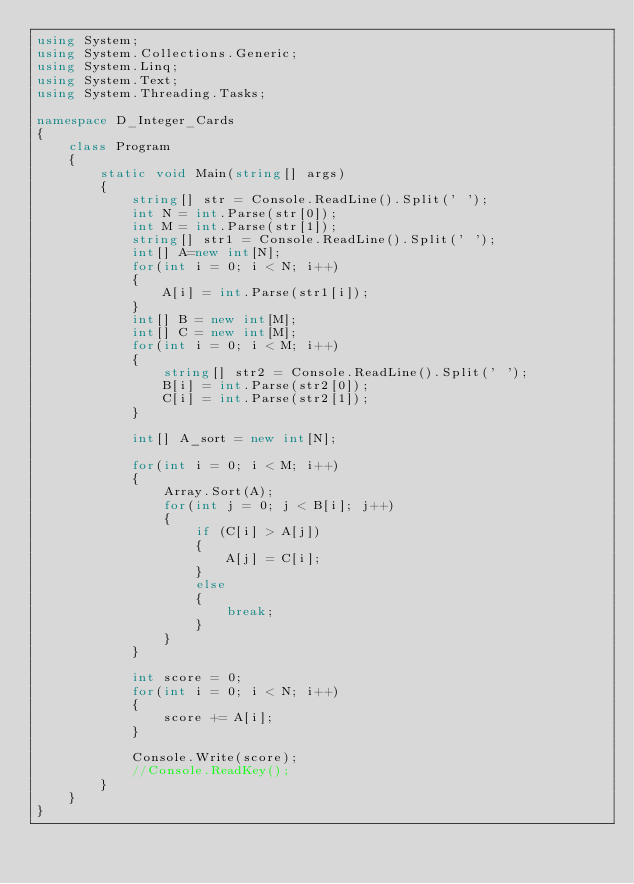<code> <loc_0><loc_0><loc_500><loc_500><_C#_>using System;
using System.Collections.Generic;
using System.Linq;
using System.Text;
using System.Threading.Tasks;

namespace D_Integer_Cards
{
    class Program
    {
        static void Main(string[] args)
        {
            string[] str = Console.ReadLine().Split(' ');
            int N = int.Parse(str[0]);
            int M = int.Parse(str[1]);
            string[] str1 = Console.ReadLine().Split(' ');
            int[] A=new int[N];
            for(int i = 0; i < N; i++)
            {
                A[i] = int.Parse(str1[i]);
            }
            int[] B = new int[M];
            int[] C = new int[M];
            for(int i = 0; i < M; i++)
            {
                string[] str2 = Console.ReadLine().Split(' ');
                B[i] = int.Parse(str2[0]);
                C[i] = int.Parse(str2[1]);
            }

            int[] A_sort = new int[N];

            for(int i = 0; i < M; i++)
            {
                Array.Sort(A);
                for(int j = 0; j < B[i]; j++)
                {
                    if (C[i] > A[j])
                    {
                        A[j] = C[i];
                    }
                    else
                    {
                        break;
                    }
                }
            }

            int score = 0;
            for(int i = 0; i < N; i++)
            {
                score += A[i];
            }

            Console.Write(score);
            //Console.ReadKey();
        }
    }
}
</code> 